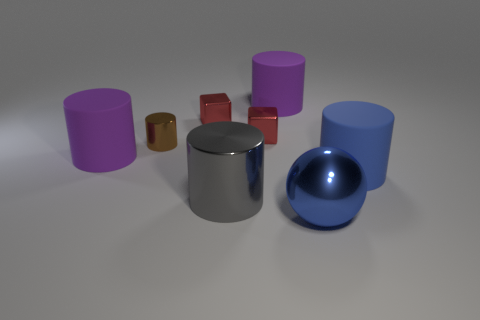There is a gray object that is the same shape as the brown object; what material is it?
Offer a terse response. Metal. How many other things are the same size as the blue rubber thing?
Offer a very short reply. 4. How many objects are there?
Provide a short and direct response. 8. Does the brown cylinder have the same material as the purple object in front of the brown metallic cylinder?
Your answer should be compact. No. What number of red objects are either balls or big metallic cylinders?
Provide a succinct answer. 0. What is the size of the gray cylinder that is made of the same material as the big blue sphere?
Your response must be concise. Large. How many big purple things have the same shape as the big blue metal thing?
Keep it short and to the point. 0. Are there more cylinders that are left of the large blue matte cylinder than tiny objects in front of the gray cylinder?
Provide a short and direct response. Yes. There is a shiny ball; does it have the same color as the metallic cylinder that is behind the blue cylinder?
Your answer should be compact. No. There is a blue object that is the same size as the blue cylinder; what is it made of?
Offer a terse response. Metal. 